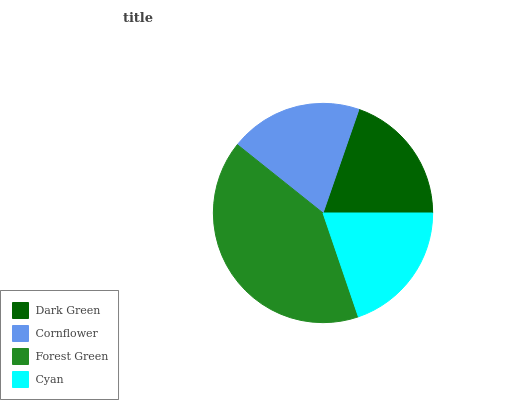Is Cornflower the minimum?
Answer yes or no. Yes. Is Forest Green the maximum?
Answer yes or no. Yes. Is Forest Green the minimum?
Answer yes or no. No. Is Cornflower the maximum?
Answer yes or no. No. Is Forest Green greater than Cornflower?
Answer yes or no. Yes. Is Cornflower less than Forest Green?
Answer yes or no. Yes. Is Cornflower greater than Forest Green?
Answer yes or no. No. Is Forest Green less than Cornflower?
Answer yes or no. No. Is Cyan the high median?
Answer yes or no. Yes. Is Dark Green the low median?
Answer yes or no. Yes. Is Forest Green the high median?
Answer yes or no. No. Is Cornflower the low median?
Answer yes or no. No. 